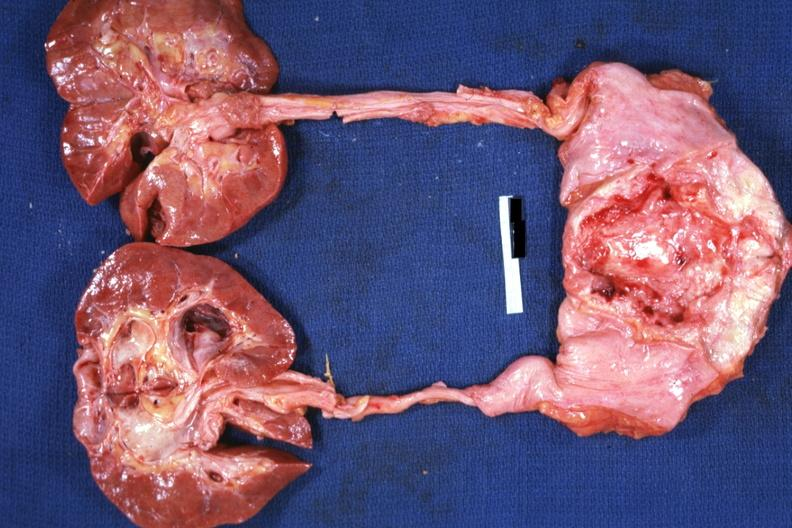s prostate present?
Answer the question using a single word or phrase. Yes 